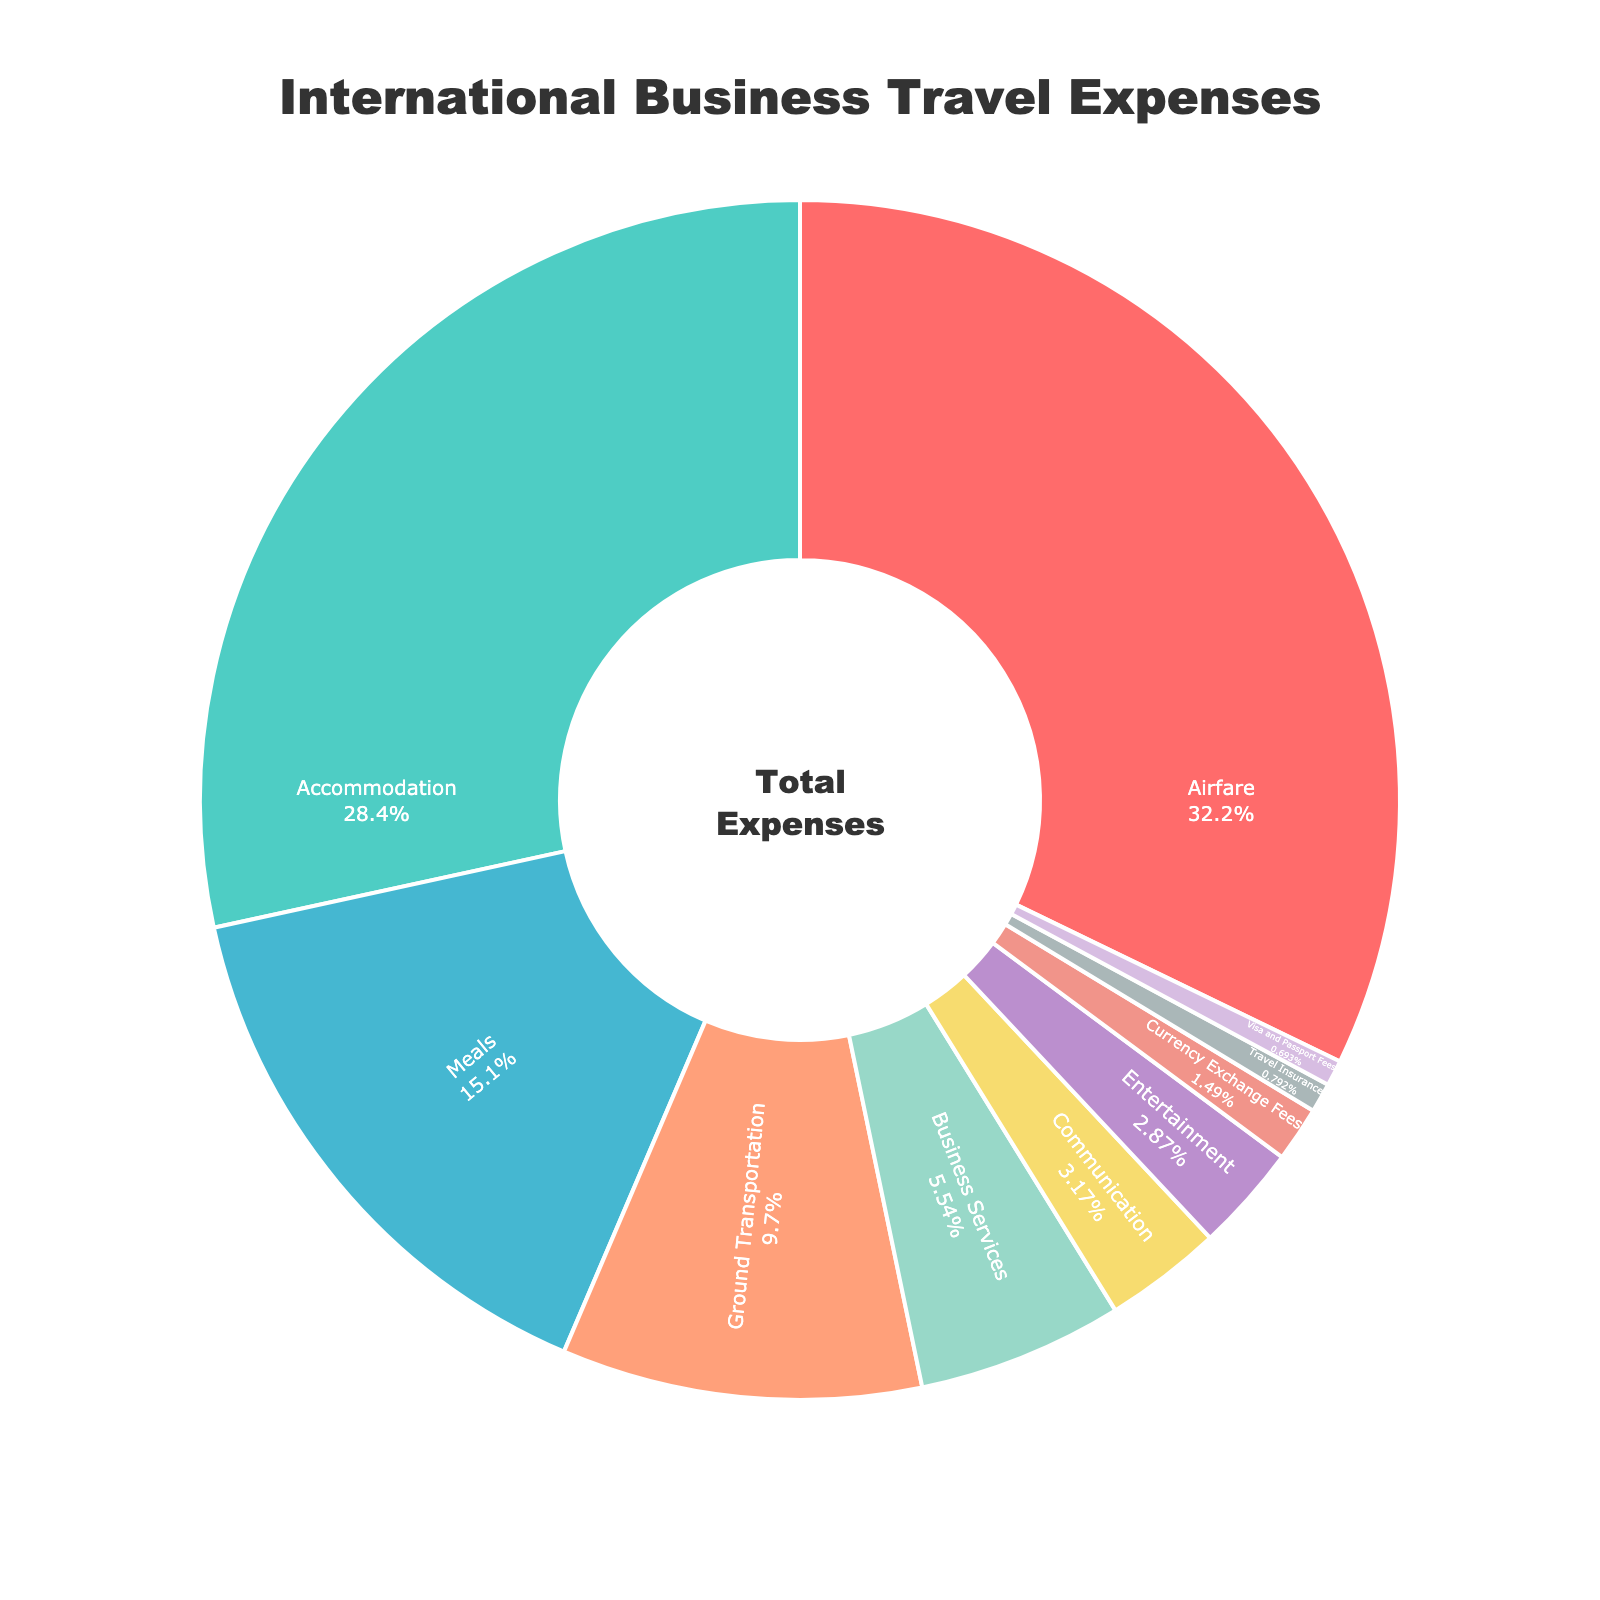What percentage of the total expenses is spent on airfare and accommodation combined? To find the combined percentage, add the percentages for airfare and accommodation: 32.5% + 28.7% = 61.2%.
Answer: 61.2% Which category has the lowest percentage of expenses? Look at the pie chart and identify the category with the smallest slice. In this case, it's Visa and Passport Fees.
Answer: Visa and Passport Fees How much more is spent on meals compared to entertainment? Subtract the percentage for entertainment from the percentage for meals: 15.3% - 2.9% = 12.4%.
Answer: 12.4% Which two categories have percentages that are closest in value? Compare the percentages of the categories and identify the pair with the smallest difference. Business Services (5.6%) and Communication (3.2%) are closest, with a difference of 2.4%.
Answer: Business Services and Communication What is the percentage difference between the highest and lowest expense categories? Subtract the percentage of the lowest expense category (Visa and Passport Fees, 0.7%) from the highest (Airfare, 32.5%): 32.5% - 0.7% = 31.8%.
Answer: 31.8% What is the average percentage of the top three most expensive categories? Add the percentages of the top three categories (Airfare, Accommodation, Meals) and divide by three: (32.5% + 28.7% + 15.3%) / 3 = 76.5% / 3 ≈ 25.5%.
Answer: 25.5% How do the combined expenses on business services and communication compare to the expenditure on ground transportation? Add the percentages for business services (5.6%) and communication (3.2%) and compare to ground transportation (9.8%): 5.6% + 3.2% = 8.8%, which is less than 9.8%.
Answer: Less What color is used to represent accommodation on the pie chart? The second category, accommodation, uses the color corresponding to its slice. It is green (#4ECDC4).
Answer: Green Is more money spent on ground transportation than on business services and currency exchange fees combined? Add the percentages for business services (5.6%) and currency exchange fees (1.5%) and compare to ground transportation (9.8%): 5.6% + 1.5% = 7.1%, which is less than 9.8%.
Answer: Yes 